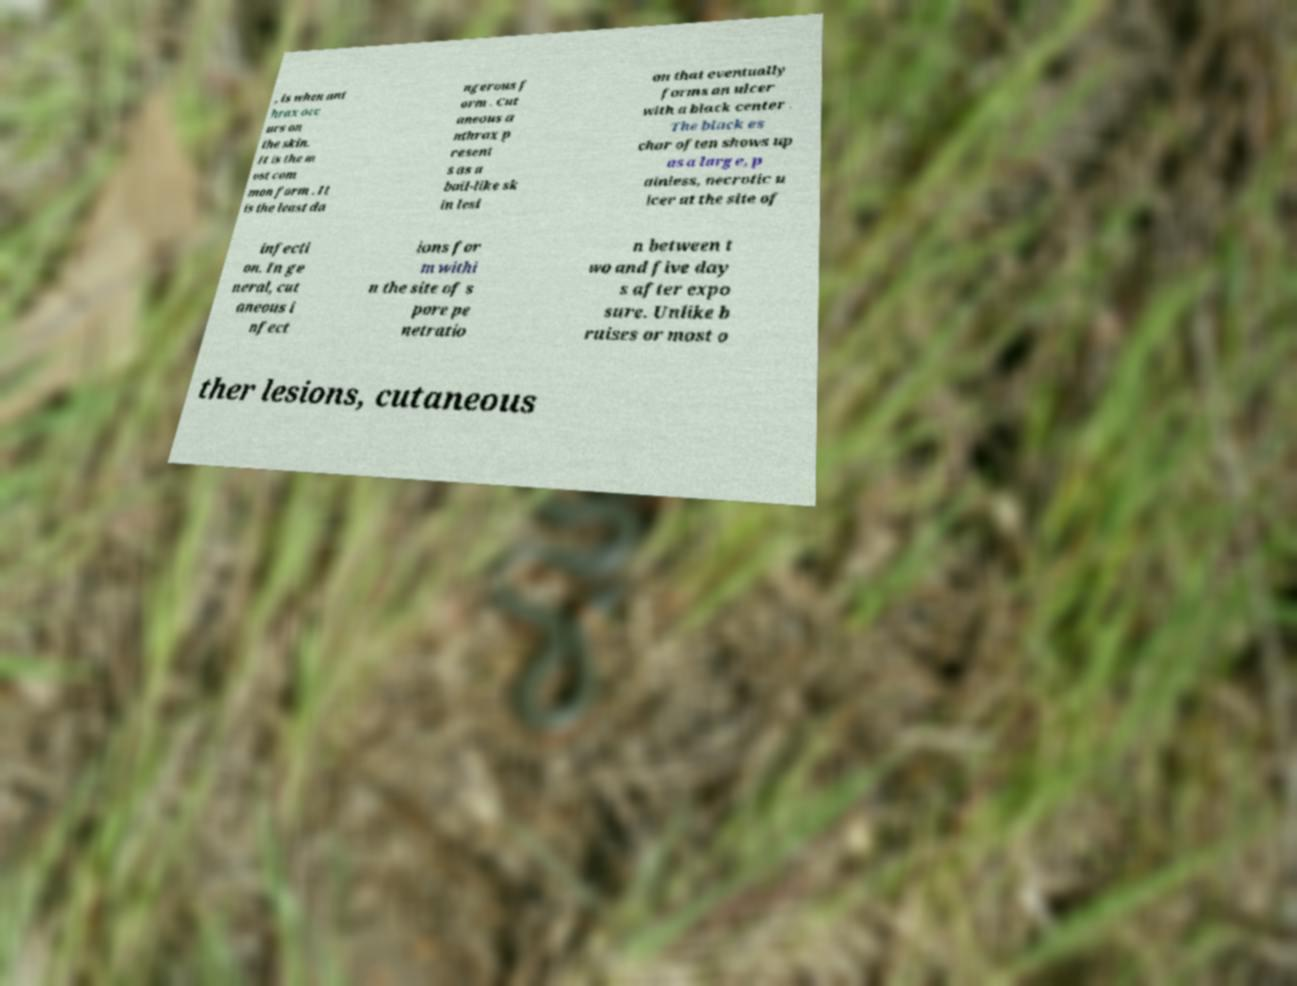There's text embedded in this image that I need extracted. Can you transcribe it verbatim? , is when ant hrax occ urs on the skin. It is the m ost com mon form . It is the least da ngerous f orm . Cut aneous a nthrax p resent s as a boil-like sk in lesi on that eventually forms an ulcer with a black center . The black es char often shows up as a large, p ainless, necrotic u lcer at the site of infecti on. In ge neral, cut aneous i nfect ions for m withi n the site of s pore pe netratio n between t wo and five day s after expo sure. Unlike b ruises or most o ther lesions, cutaneous 